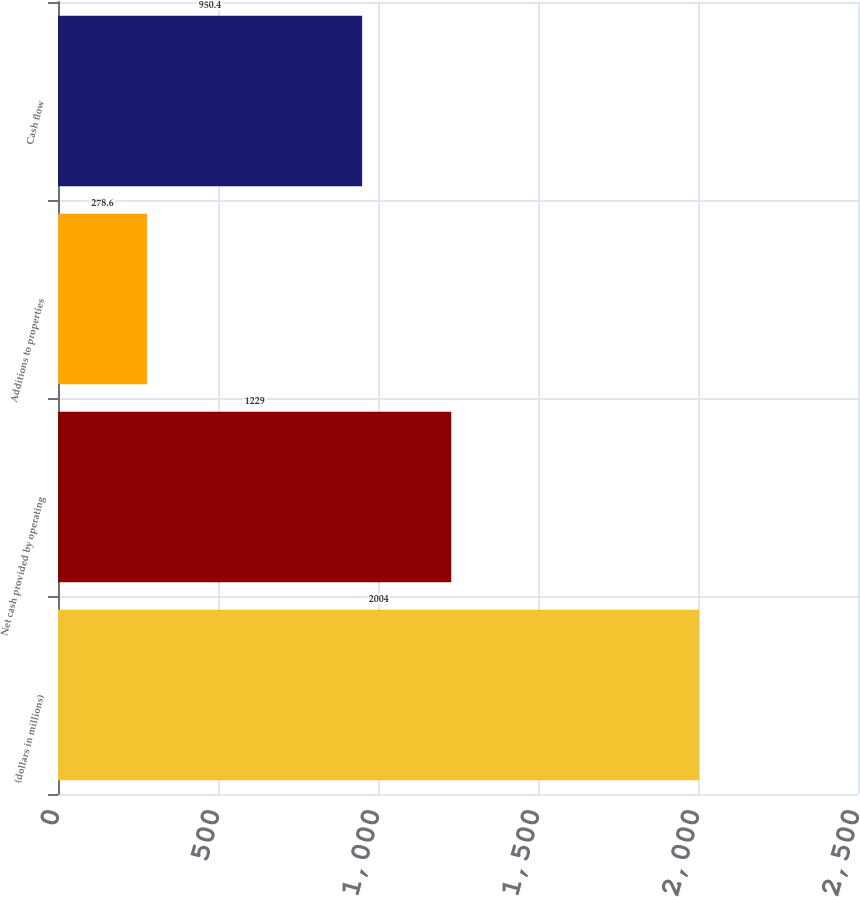Convert chart to OTSL. <chart><loc_0><loc_0><loc_500><loc_500><bar_chart><fcel>(dollars in millions)<fcel>Net cash provided by operating<fcel>Additions to properties<fcel>Cash flow<nl><fcel>2004<fcel>1229<fcel>278.6<fcel>950.4<nl></chart> 